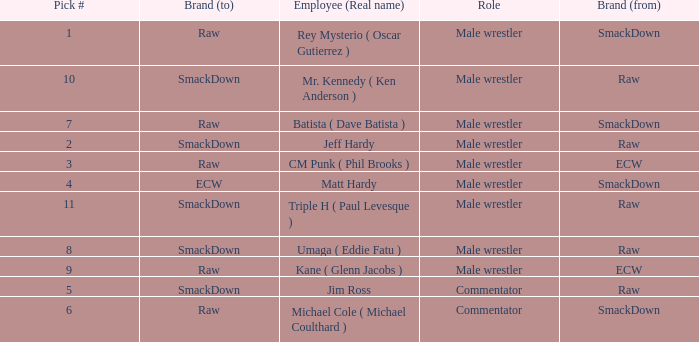Help me parse the entirety of this table. {'header': ['Pick #', 'Brand (to)', 'Employee (Real name)', 'Role', 'Brand (from)'], 'rows': [['1', 'Raw', 'Rey Mysterio ( Oscar Gutierrez )', 'Male wrestler', 'SmackDown'], ['10', 'SmackDown', 'Mr. Kennedy ( Ken Anderson )', 'Male wrestler', 'Raw'], ['7', 'Raw', 'Batista ( Dave Batista )', 'Male wrestler', 'SmackDown'], ['2', 'SmackDown', 'Jeff Hardy', 'Male wrestler', 'Raw'], ['3', 'Raw', 'CM Punk ( Phil Brooks )', 'Male wrestler', 'ECW'], ['4', 'ECW', 'Matt Hardy', 'Male wrestler', 'SmackDown'], ['11', 'SmackDown', 'Triple H ( Paul Levesque )', 'Male wrestler', 'Raw'], ['8', 'SmackDown', 'Umaga ( Eddie Fatu )', 'Male wrestler', 'Raw'], ['9', 'Raw', 'Kane ( Glenn Jacobs )', 'Male wrestler', 'ECW'], ['5', 'SmackDown', 'Jim Ross', 'Commentator', 'Raw'], ['6', 'Raw', 'Michael Cole ( Michael Coulthard )', 'Commentator', 'SmackDown']]} What is the real name of the male wrestler from Raw with a pick # smaller than 6? Jeff Hardy. 